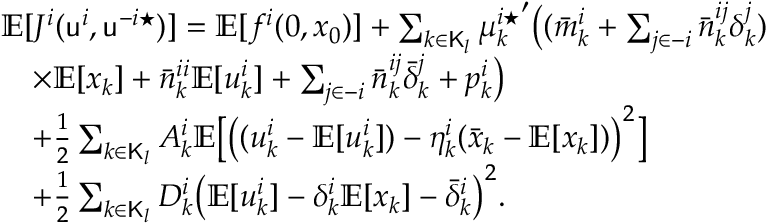Convert formula to latex. <formula><loc_0><loc_0><loc_500><loc_500>\begin{array} { r l } & { \mathbb { E } [ J ^ { i } ( u ^ { i } , u ^ { - i ^ { * } } ) ] = \mathbb { E } [ f ^ { i } ( 0 , x _ { 0 } ) ] + \sum _ { k \in K _ { l } } { \mu _ { k } ^ { i ^ { * } } } ^ { \prime } \left ( ( \bar { m } _ { k } ^ { i } + \sum _ { j \in - i } \bar { n } _ { k } ^ { i j } \delta _ { k } ^ { j } ) } \\ & { \quad \times \mathbb { E } [ x _ { k } ] + \bar { n } _ { k } ^ { i i } \mathbb { E } [ u _ { k } ^ { i } ] + \sum _ { j \in - i } \bar { n } _ { k } ^ { i j } \bar { \delta } _ { k } ^ { j } + p _ { k } ^ { i } \right ) } \\ & { \quad + \frac { 1 } { 2 } \sum _ { k \in K _ { l } } A _ { k } ^ { i } \mathbb { E } \left [ \left ( ( u _ { k } ^ { i } - \mathbb { E } [ u _ { k } ^ { i } ] ) - \eta _ { k } ^ { i } ( \bar { x } _ { k } - \mathbb { E } [ x _ { k } ] ) \right ) ^ { 2 } \right ] } \\ & { \quad + \frac { 1 } { 2 } \sum _ { k \in K _ { l } } D _ { k } ^ { i } \left ( \mathbb { E } [ u _ { k } ^ { i } ] - \delta _ { k } ^ { i } \mathbb { E } [ x _ { k } ] - \bar { \delta } _ { k } ^ { i } \right ) ^ { 2 } . } \end{array}</formula> 